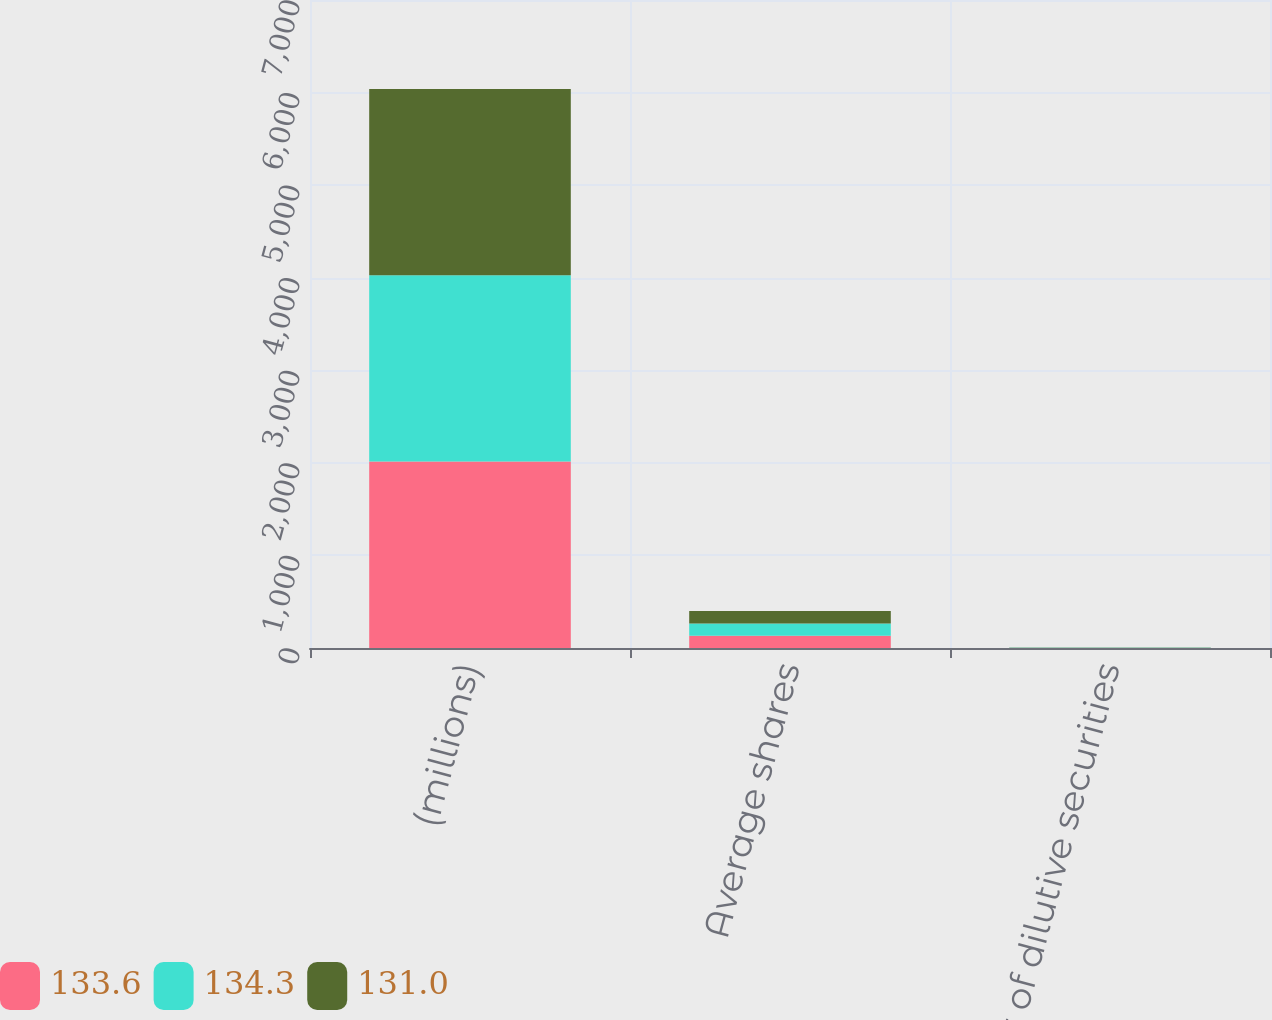Convert chart to OTSL. <chart><loc_0><loc_0><loc_500><loc_500><stacked_bar_chart><ecel><fcel>(millions)<fcel>Average shares<fcel>Effect of dilutive securities<nl><fcel>133.6<fcel>2014<fcel>131<fcel>1.1<nl><fcel>134.3<fcel>2013<fcel>133.6<fcel>1.5<nl><fcel>131<fcel>2012<fcel>134.3<fcel>1.6<nl></chart> 